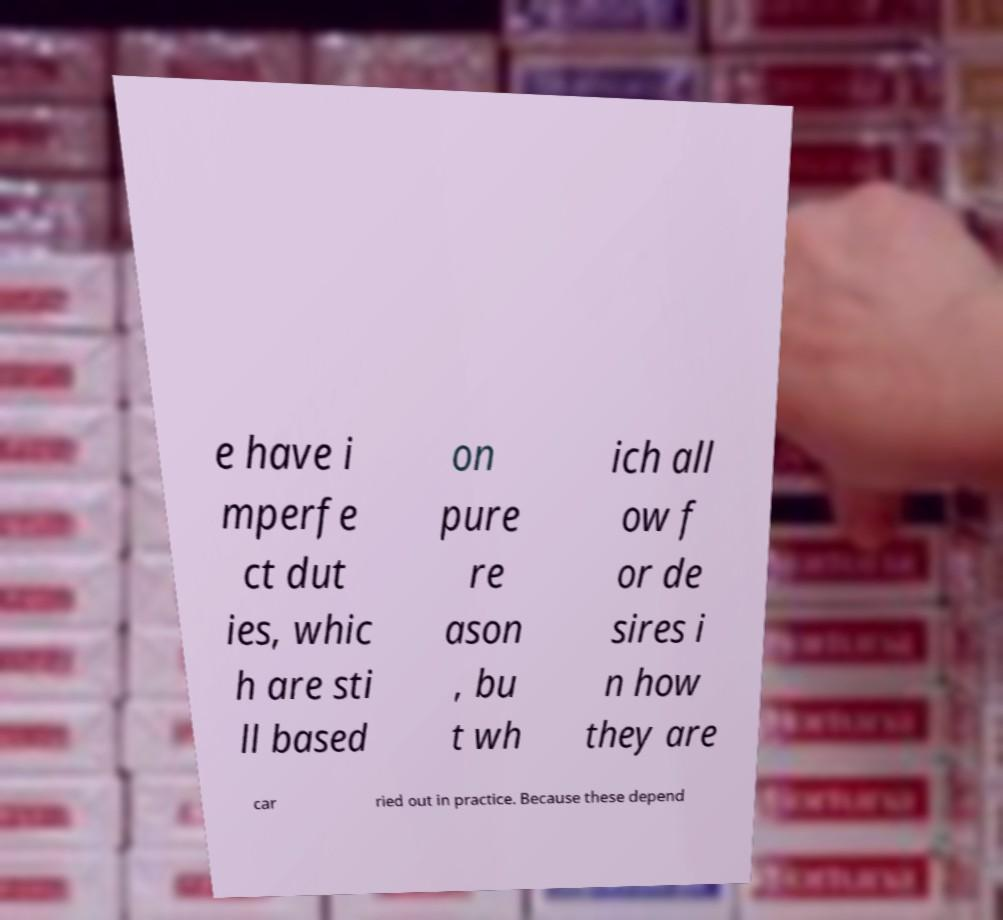Please read and relay the text visible in this image. What does it say? e have i mperfe ct dut ies, whic h are sti ll based on pure re ason , bu t wh ich all ow f or de sires i n how they are car ried out in practice. Because these depend 